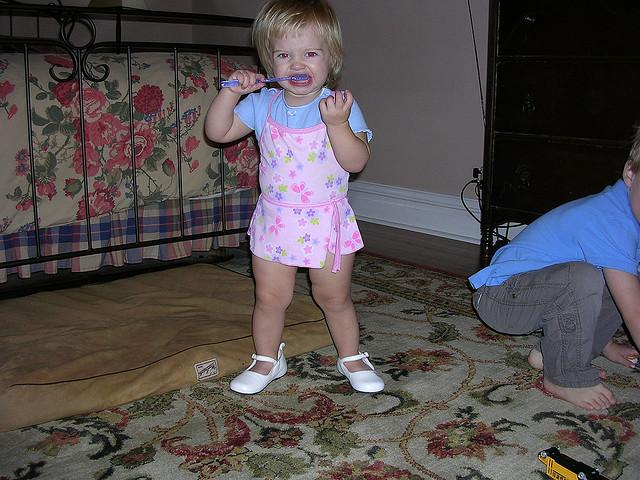Why are her eyes red? Please explain your reasoning. reflected light. There is glare from the camera. 